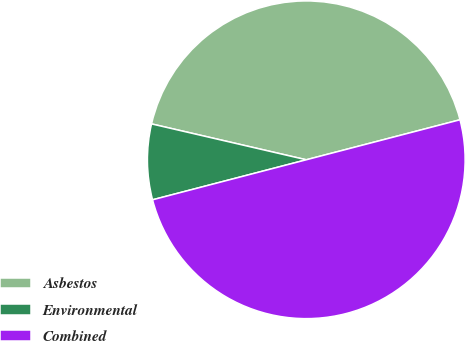Convert chart to OTSL. <chart><loc_0><loc_0><loc_500><loc_500><pie_chart><fcel>Asbestos<fcel>Environmental<fcel>Combined<nl><fcel>42.32%<fcel>7.68%<fcel>50.0%<nl></chart> 